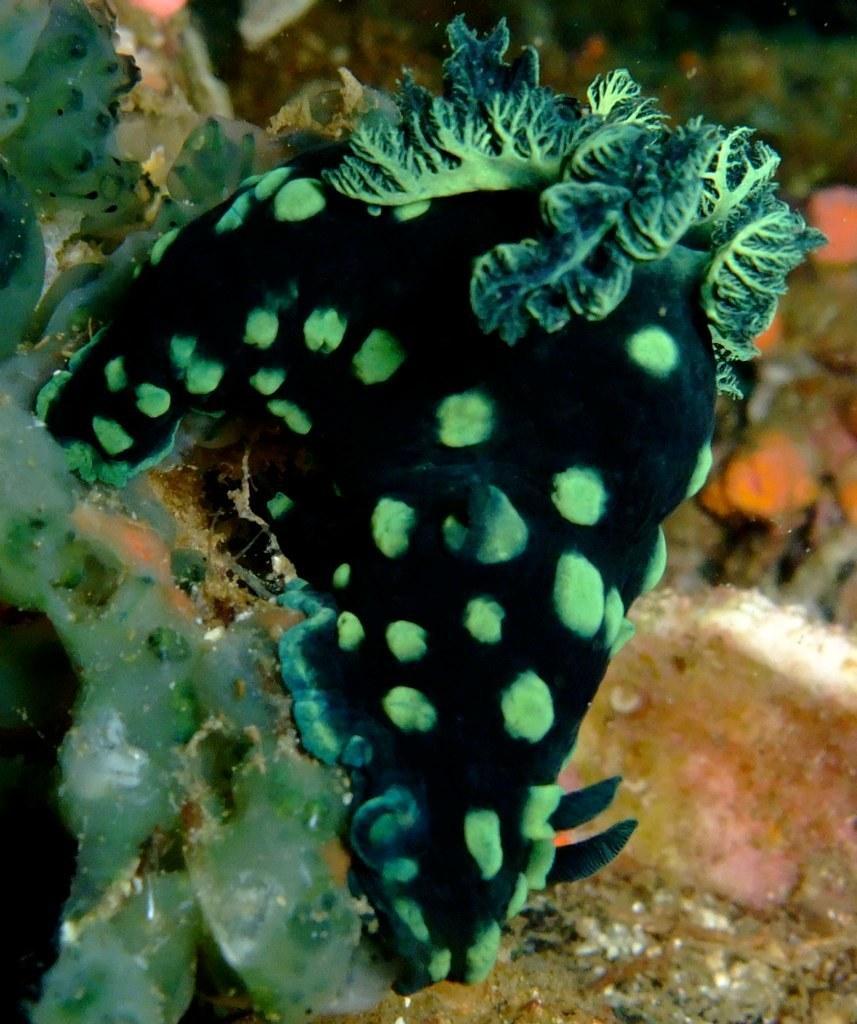Can you describe this image briefly? In this picture we can see underwater corals. 